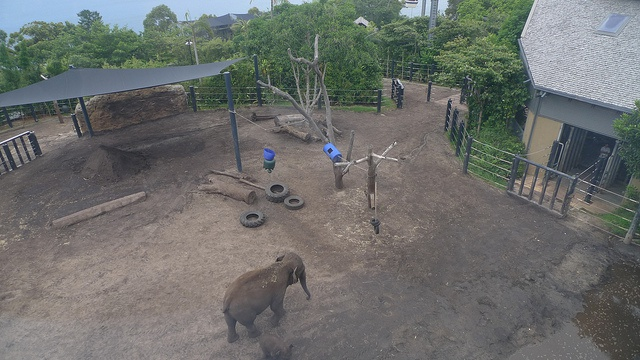Describe the objects in this image and their specific colors. I can see elephant in lightblue, gray, and black tones and people in lightblue, gray, black, and darkblue tones in this image. 